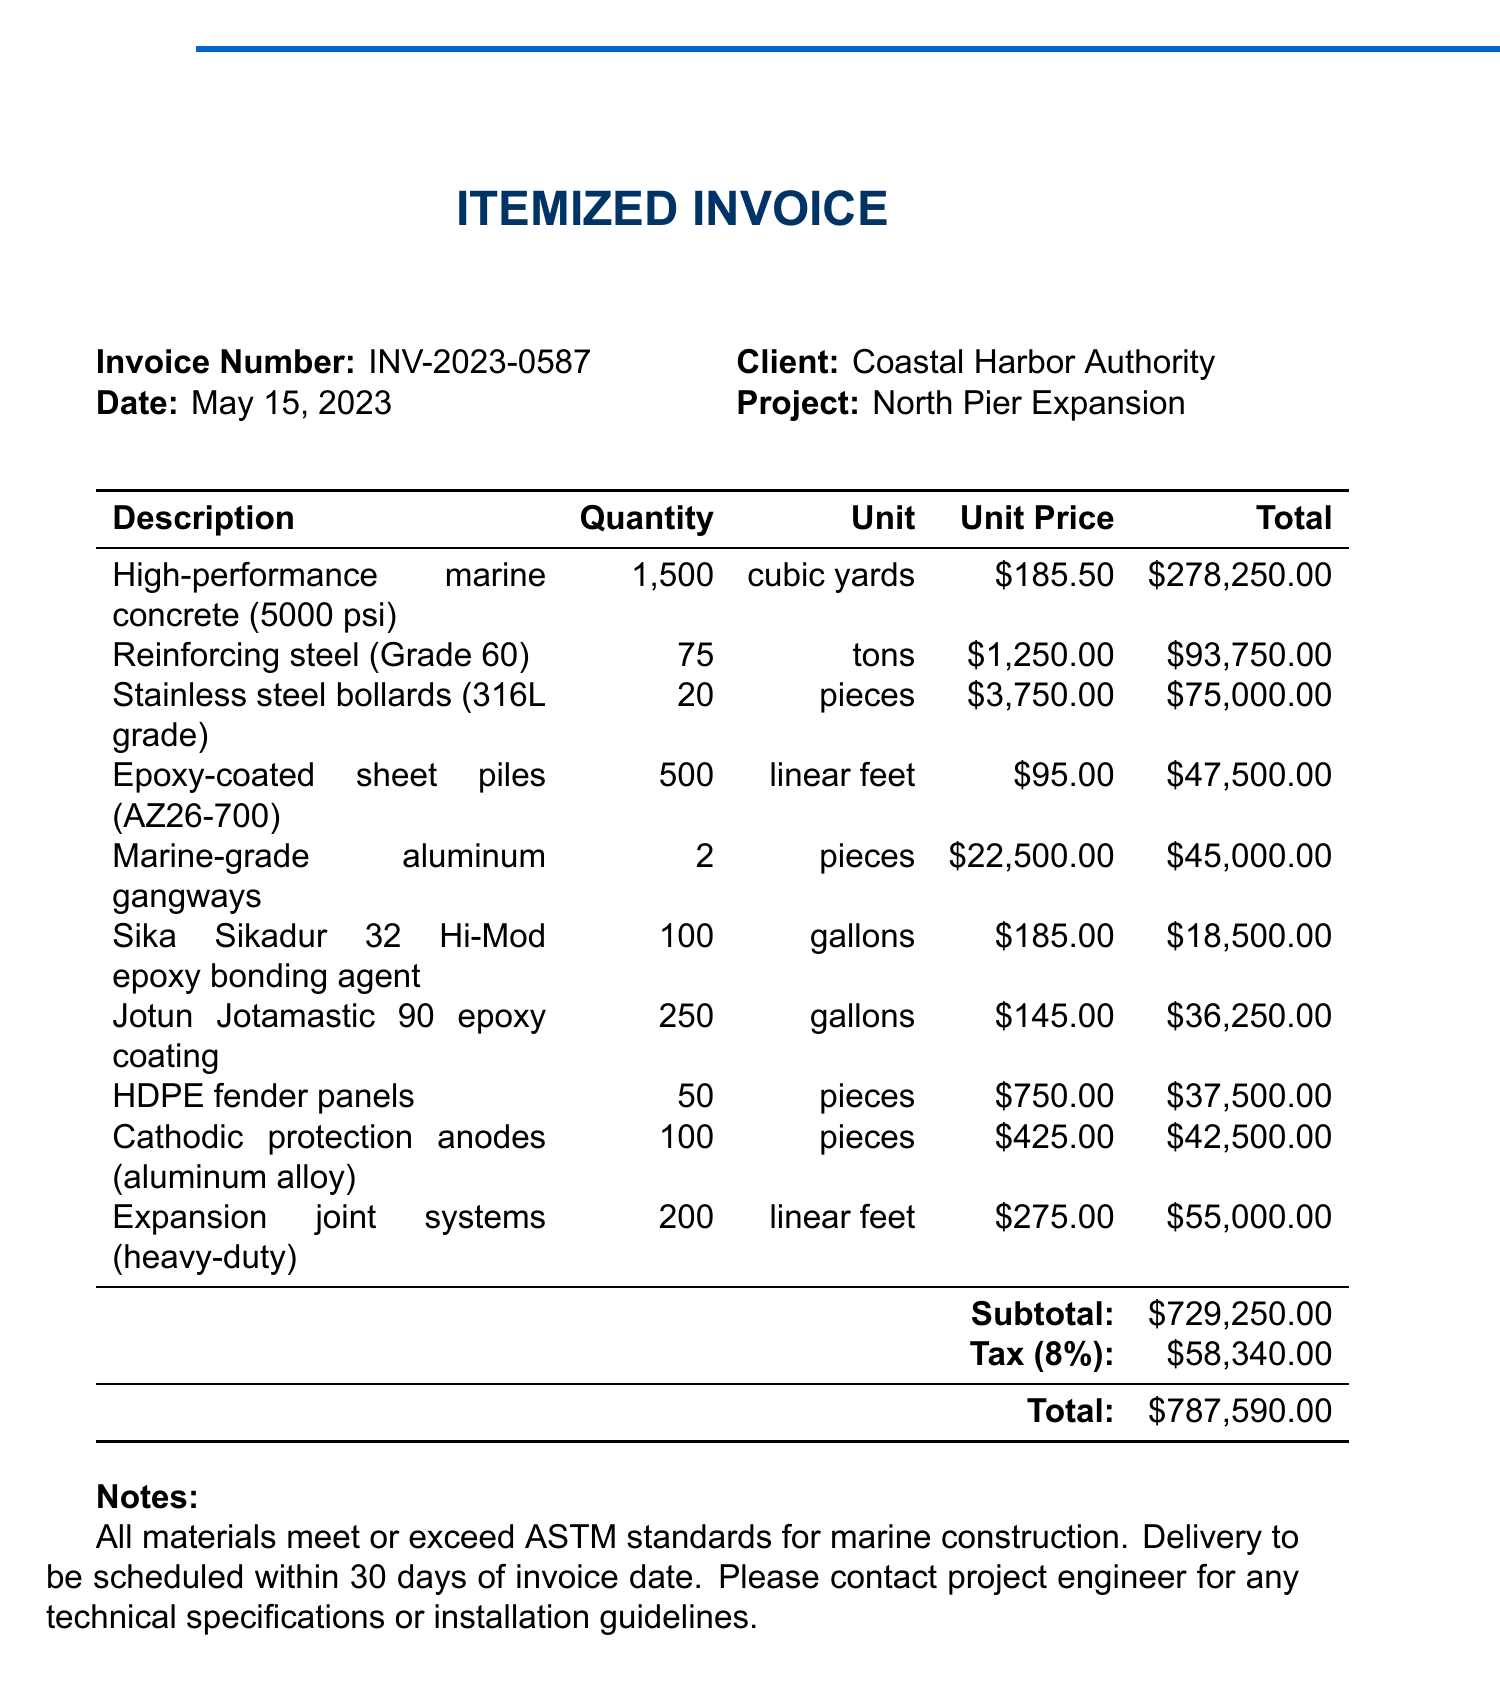What is the invoice number? The invoice number is specified in the document under the invoice details.
Answer: INV-2023-0587 What is the subtotal amount? The subtotal amount is presented in the invoice just before the tax and total lines.
Answer: $729,250.00 How many pieces of stainless steel bollards are included? The quantity of stainless steel bollards is listed in the items section of the invoice.
Answer: 20 What is the total tax amount? The total tax amount can be found near the bottom of the invoice, labeled as tax.
Answer: $58,340.00 What type of epoxy coating is listed? The specific type of epoxy coating is included in the item description section of the invoice.
Answer: Jotun Jotamastic 90 epoxy coating How many gallons of Sika Sikadur 32 Hi-Mod epoxy bonding agent were purchased? The quantity of Sika Sikadur 32 Hi-Mod epoxy bonding agent is provided in the itemized section.
Answer: 100 What is the total amount due? The total amount due is found at the very bottom of the invoice, encompassing all charges.
Answer: $787,590.00 What material is used for the fender panels? The material for the fender panels is detailed in the description of one of the items.
Answer: HDPE How many linear feet of epoxy-coated sheet piles are included? This quantity is listed in the product details for the epoxy-coated sheet piles on the invoice.
Answer: 500 What does the invoice note mention regarding material standards? The note at the bottom contains important information about material standards.
Answer: All materials meet or exceed ASTM standards for marine construction 